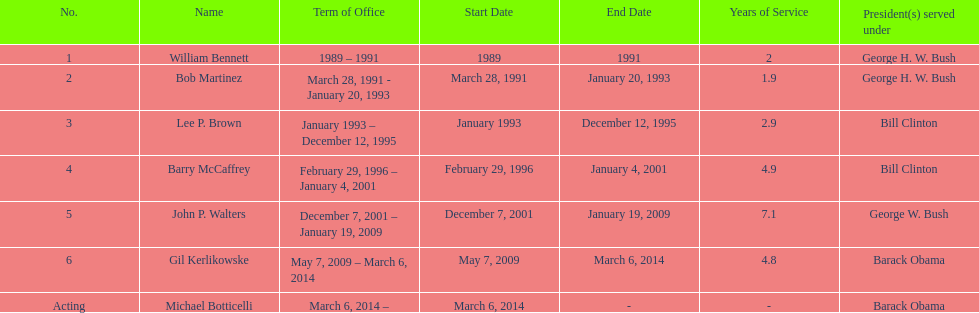What were the total number of years bob martinez served in office? 2. Could you parse the entire table as a dict? {'header': ['No.', 'Name', 'Term of Office', 'Start Date', 'End Date', 'Years of Service', 'President(s) served under'], 'rows': [['1', 'William Bennett', '1989 – 1991', '1989', '1991', '2', 'George H. W. Bush'], ['2', 'Bob Martinez', 'March 28, 1991 - January 20, 1993', 'March 28, 1991', 'January 20, 1993', '1.9', 'George H. W. Bush'], ['3', 'Lee P. Brown', 'January 1993 – December 12, 1995', 'January 1993', 'December 12, 1995', '2.9', 'Bill Clinton'], ['4', 'Barry McCaffrey', 'February 29, 1996 – January 4, 2001', 'February 29, 1996', 'January 4, 2001', '4.9', 'Bill Clinton'], ['5', 'John P. Walters', 'December 7, 2001 – January 19, 2009', 'December 7, 2001', 'January 19, 2009', '7.1', 'George W. Bush'], ['6', 'Gil Kerlikowske', 'May 7, 2009 – March 6, 2014', 'May 7, 2009', 'March 6, 2014', '4.8', 'Barack Obama'], ['Acting', 'Michael Botticelli', 'March 6, 2014 –', 'March 6, 2014', '-', '-', 'Barack Obama']]} 